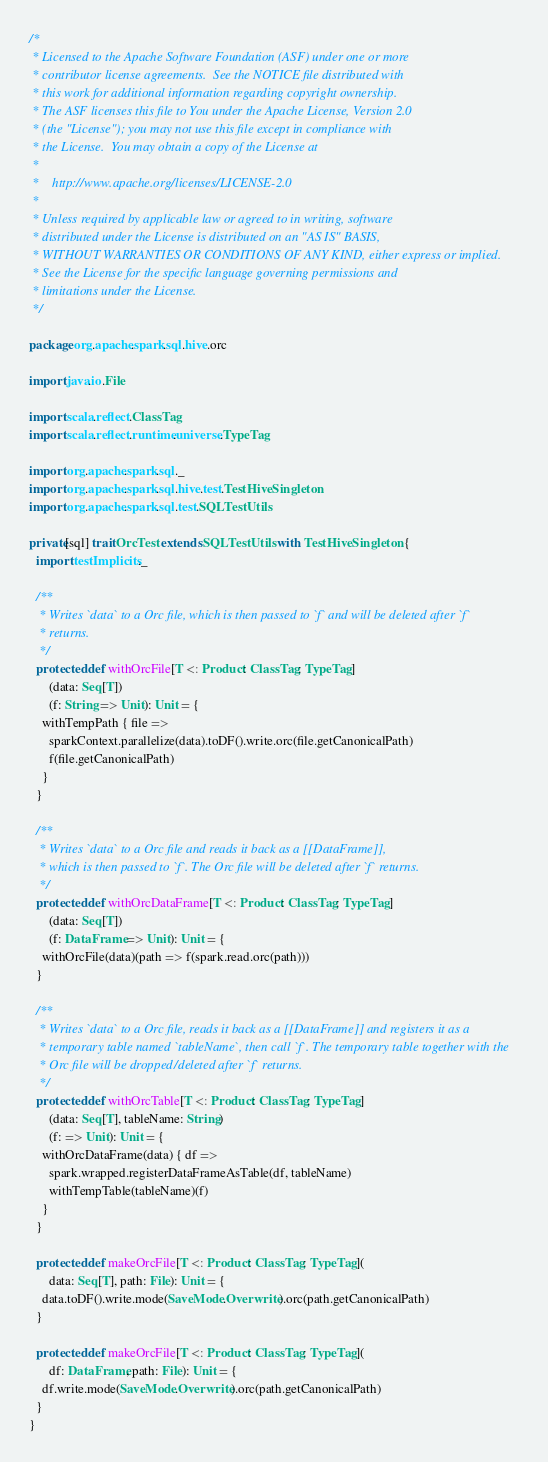Convert code to text. <code><loc_0><loc_0><loc_500><loc_500><_Scala_>/*
 * Licensed to the Apache Software Foundation (ASF) under one or more
 * contributor license agreements.  See the NOTICE file distributed with
 * this work for additional information regarding copyright ownership.
 * The ASF licenses this file to You under the Apache License, Version 2.0
 * (the "License"); you may not use this file except in compliance with
 * the License.  You may obtain a copy of the License at
 *
 *    http://www.apache.org/licenses/LICENSE-2.0
 *
 * Unless required by applicable law or agreed to in writing, software
 * distributed under the License is distributed on an "AS IS" BASIS,
 * WITHOUT WARRANTIES OR CONDITIONS OF ANY KIND, either express or implied.
 * See the License for the specific language governing permissions and
 * limitations under the License.
 */

package org.apache.spark.sql.hive.orc

import java.io.File

import scala.reflect.ClassTag
import scala.reflect.runtime.universe.TypeTag

import org.apache.spark.sql._
import org.apache.spark.sql.hive.test.TestHiveSingleton
import org.apache.spark.sql.test.SQLTestUtils

private[sql] trait OrcTest extends SQLTestUtils with TestHiveSingleton {
  import testImplicits._

  /**
   * Writes `data` to a Orc file, which is then passed to `f` and will be deleted after `f`
   * returns.
   */
  protected def withOrcFile[T <: Product: ClassTag: TypeTag]
      (data: Seq[T])
      (f: String => Unit): Unit = {
    withTempPath { file =>
      sparkContext.parallelize(data).toDF().write.orc(file.getCanonicalPath)
      f(file.getCanonicalPath)
    }
  }

  /**
   * Writes `data` to a Orc file and reads it back as a [[DataFrame]],
   * which is then passed to `f`. The Orc file will be deleted after `f` returns.
   */
  protected def withOrcDataFrame[T <: Product: ClassTag: TypeTag]
      (data: Seq[T])
      (f: DataFrame => Unit): Unit = {
    withOrcFile(data)(path => f(spark.read.orc(path)))
  }

  /**
   * Writes `data` to a Orc file, reads it back as a [[DataFrame]] and registers it as a
   * temporary table named `tableName`, then call `f`. The temporary table together with the
   * Orc file will be dropped/deleted after `f` returns.
   */
  protected def withOrcTable[T <: Product: ClassTag: TypeTag]
      (data: Seq[T], tableName: String)
      (f: => Unit): Unit = {
    withOrcDataFrame(data) { df =>
      spark.wrapped.registerDataFrameAsTable(df, tableName)
      withTempTable(tableName)(f)
    }
  }

  protected def makeOrcFile[T <: Product: ClassTag: TypeTag](
      data: Seq[T], path: File): Unit = {
    data.toDF().write.mode(SaveMode.Overwrite).orc(path.getCanonicalPath)
  }

  protected def makeOrcFile[T <: Product: ClassTag: TypeTag](
      df: DataFrame, path: File): Unit = {
    df.write.mode(SaveMode.Overwrite).orc(path.getCanonicalPath)
  }
}
</code> 